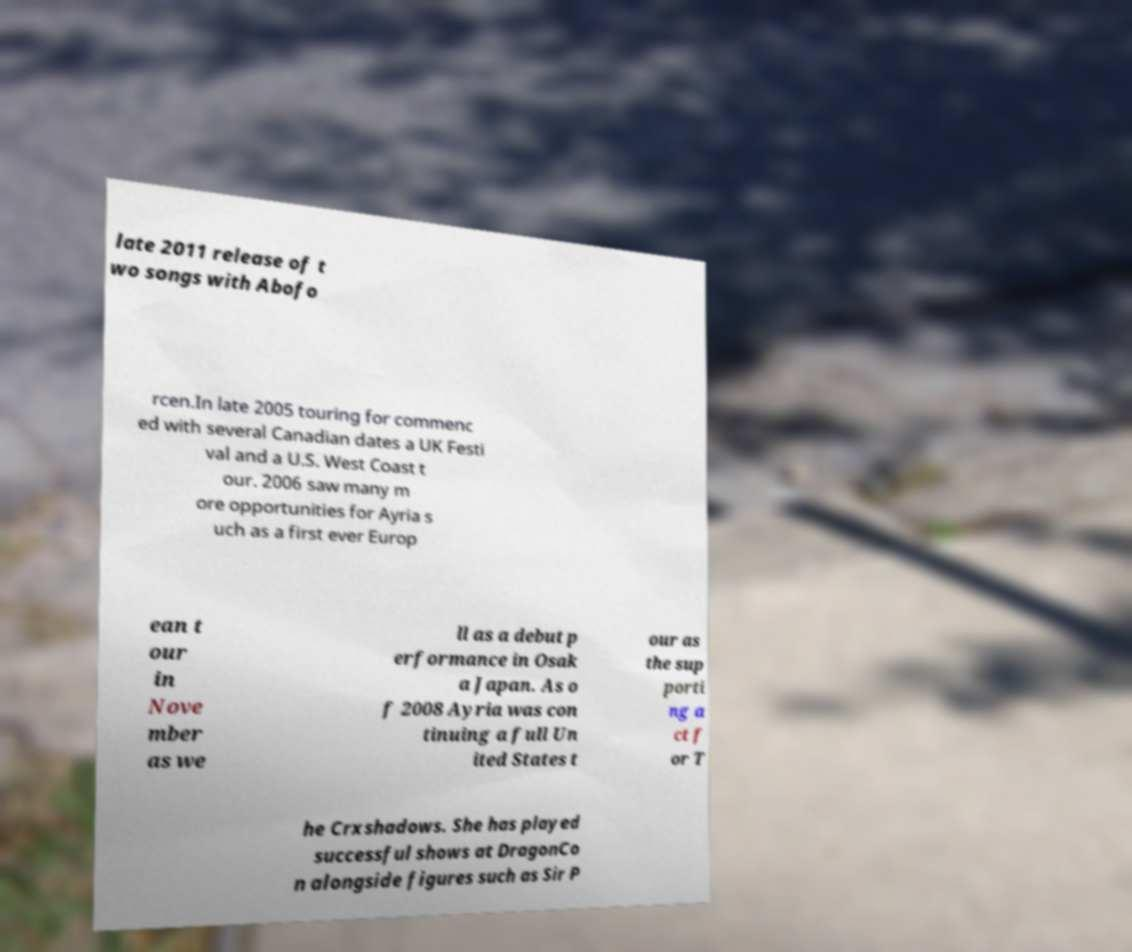There's text embedded in this image that I need extracted. Can you transcribe it verbatim? late 2011 release of t wo songs with Abofo rcen.In late 2005 touring for commenc ed with several Canadian dates a UK Festi val and a U.S. West Coast t our. 2006 saw many m ore opportunities for Ayria s uch as a first ever Europ ean t our in Nove mber as we ll as a debut p erformance in Osak a Japan. As o f 2008 Ayria was con tinuing a full Un ited States t our as the sup porti ng a ct f or T he Crxshadows. She has played successful shows at DragonCo n alongside figures such as Sir P 